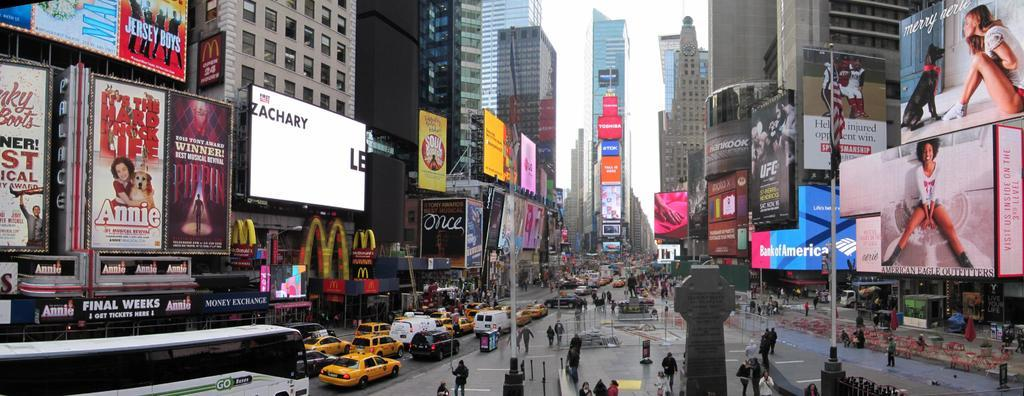<image>
Relay a brief, clear account of the picture shown. A busy street with an ad for a movie called Annie on the left. 